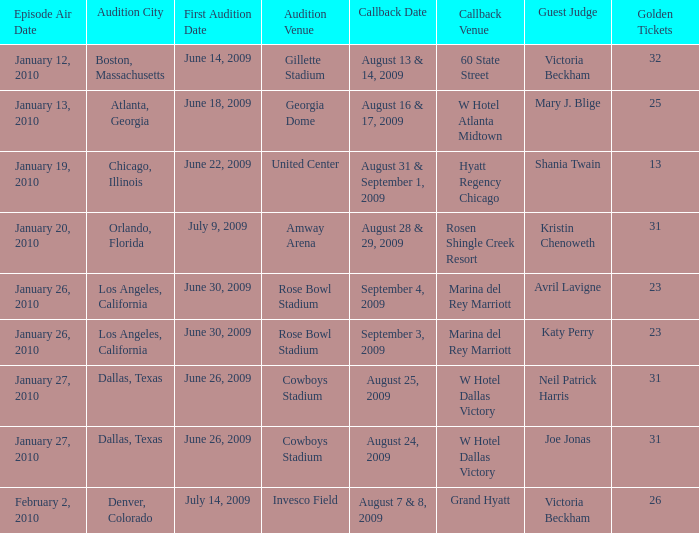Name the golden ticket for invesco field 26.0. 